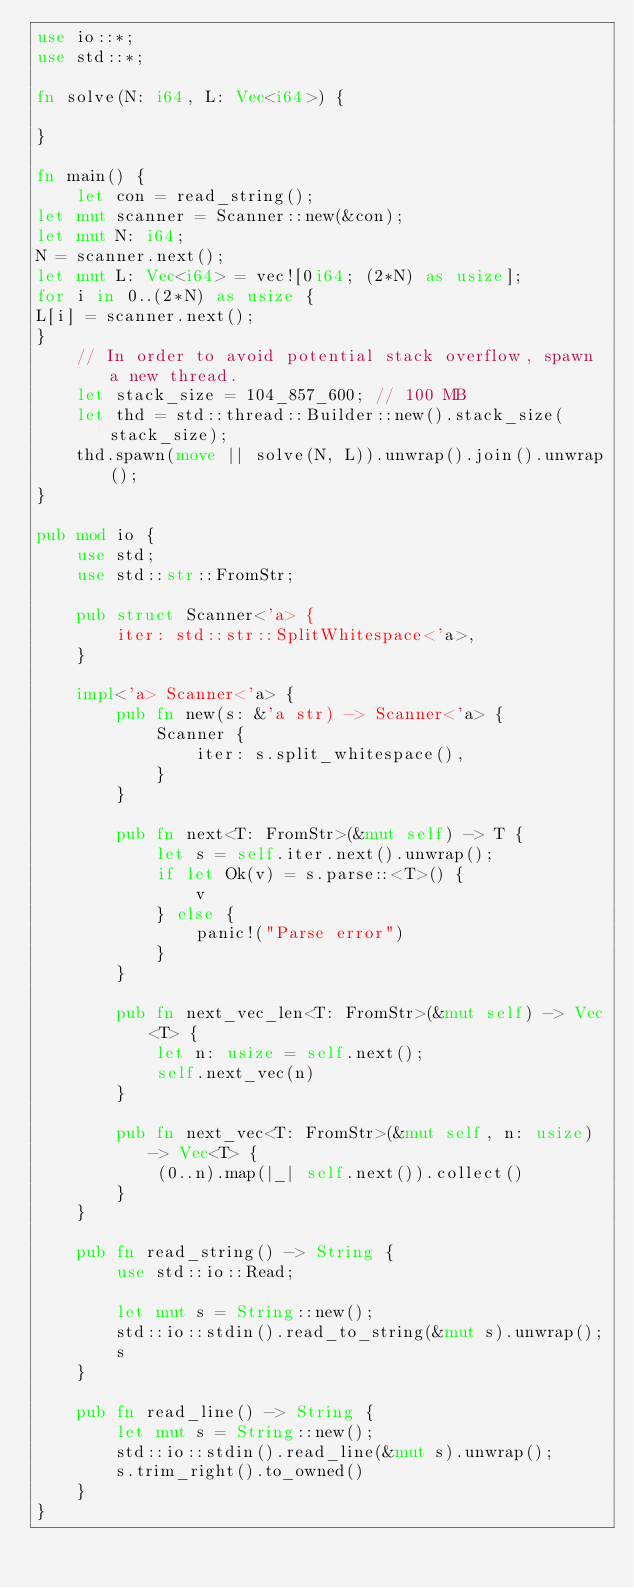Convert code to text. <code><loc_0><loc_0><loc_500><loc_500><_Rust_>use io::*;
use std::*;

fn solve(N: i64, L: Vec<i64>) {

}

fn main() {
    let con = read_string();
let mut scanner = Scanner::new(&con);
let mut N: i64;
N = scanner.next();
let mut L: Vec<i64> = vec![0i64; (2*N) as usize];
for i in 0..(2*N) as usize {
L[i] = scanner.next();
}
    // In order to avoid potential stack overflow, spawn a new thread.
    let stack_size = 104_857_600; // 100 MB
    let thd = std::thread::Builder::new().stack_size(stack_size);
    thd.spawn(move || solve(N, L)).unwrap().join().unwrap();
}

pub mod io {
    use std;
    use std::str::FromStr;

    pub struct Scanner<'a> {
        iter: std::str::SplitWhitespace<'a>,
    }

    impl<'a> Scanner<'a> {
        pub fn new(s: &'a str) -> Scanner<'a> {
            Scanner {
                iter: s.split_whitespace(),
            }
        }

        pub fn next<T: FromStr>(&mut self) -> T {
            let s = self.iter.next().unwrap();
            if let Ok(v) = s.parse::<T>() {
                v
            } else {
                panic!("Parse error")
            }
        }

        pub fn next_vec_len<T: FromStr>(&mut self) -> Vec<T> {
            let n: usize = self.next();
            self.next_vec(n)
        }

        pub fn next_vec<T: FromStr>(&mut self, n: usize) -> Vec<T> {
            (0..n).map(|_| self.next()).collect()
        }
    }

    pub fn read_string() -> String {
        use std::io::Read;

        let mut s = String::new();
        std::io::stdin().read_to_string(&mut s).unwrap();
        s
    }

    pub fn read_line() -> String {
        let mut s = String::new();
        std::io::stdin().read_line(&mut s).unwrap();
        s.trim_right().to_owned()
    }
}
</code> 